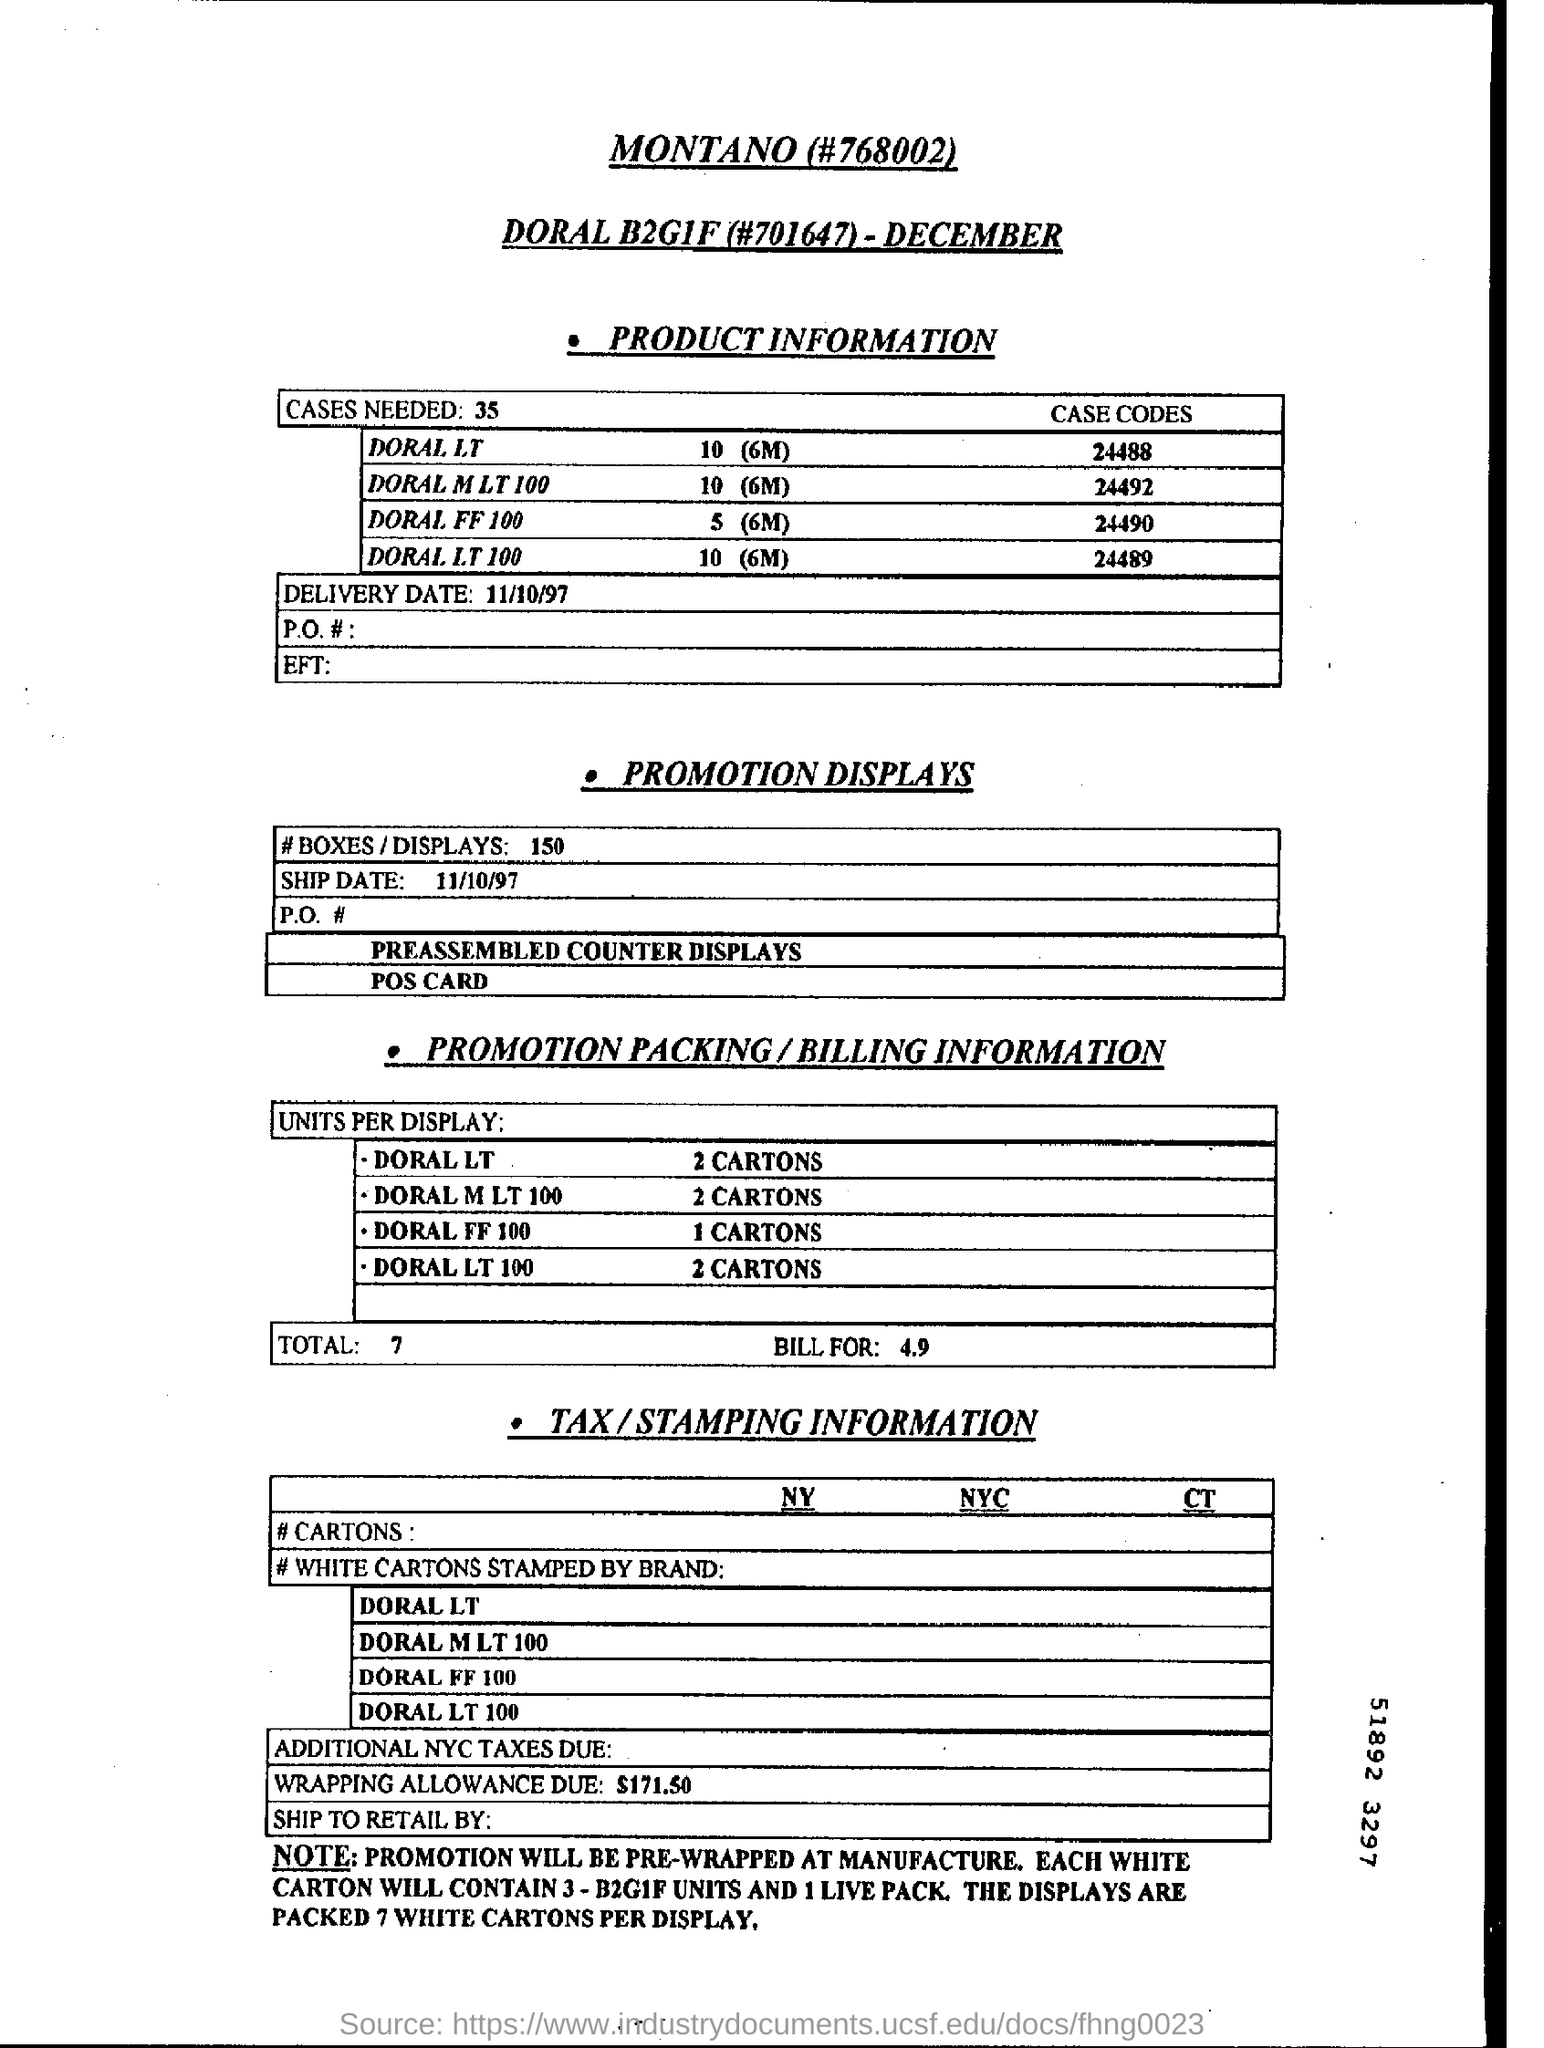How many cases are needed?
Your answer should be very brief. 35. What is the case code of DORAL LT?
Make the answer very short. 24488. What is the delivery date?
Give a very brief answer. 11/10/97. How many units per display for DORAL LT 100?
Provide a short and direct response. 2 CARTONS. What is the wrapping allowance due?
Offer a very short reply. $171.50. 